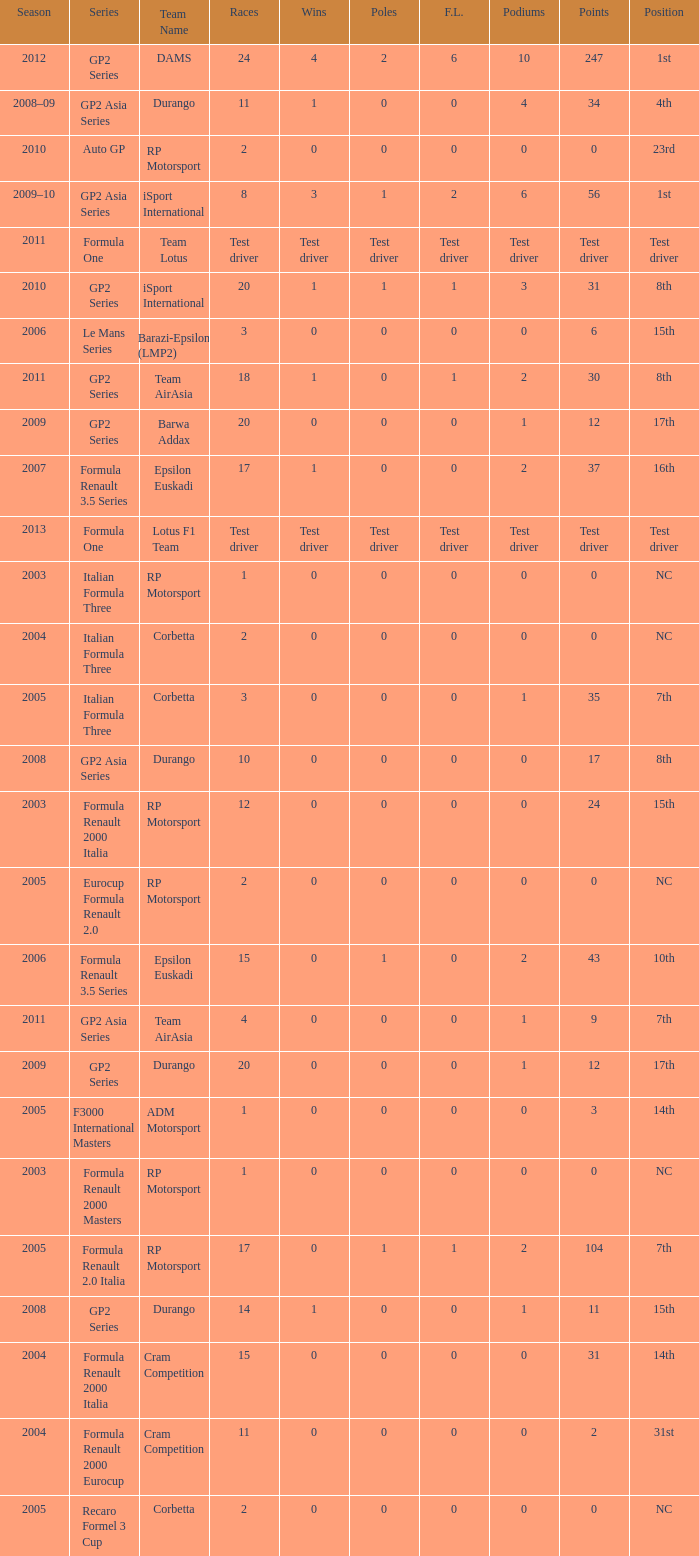What is the number of poles with 104 points? 1.0. 